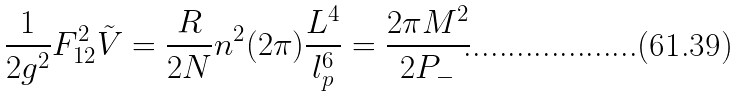Convert formula to latex. <formula><loc_0><loc_0><loc_500><loc_500>\frac { 1 } { 2 g ^ { 2 } } F ^ { 2 } _ { 1 2 } \tilde { V } = \frac { R } { 2 N } n ^ { 2 } ( 2 \pi ) \frac { L ^ { 4 } } { l ^ { 6 } _ { p } } = \frac { 2 \pi M ^ { 2 } } { 2 P _ { - } }</formula> 